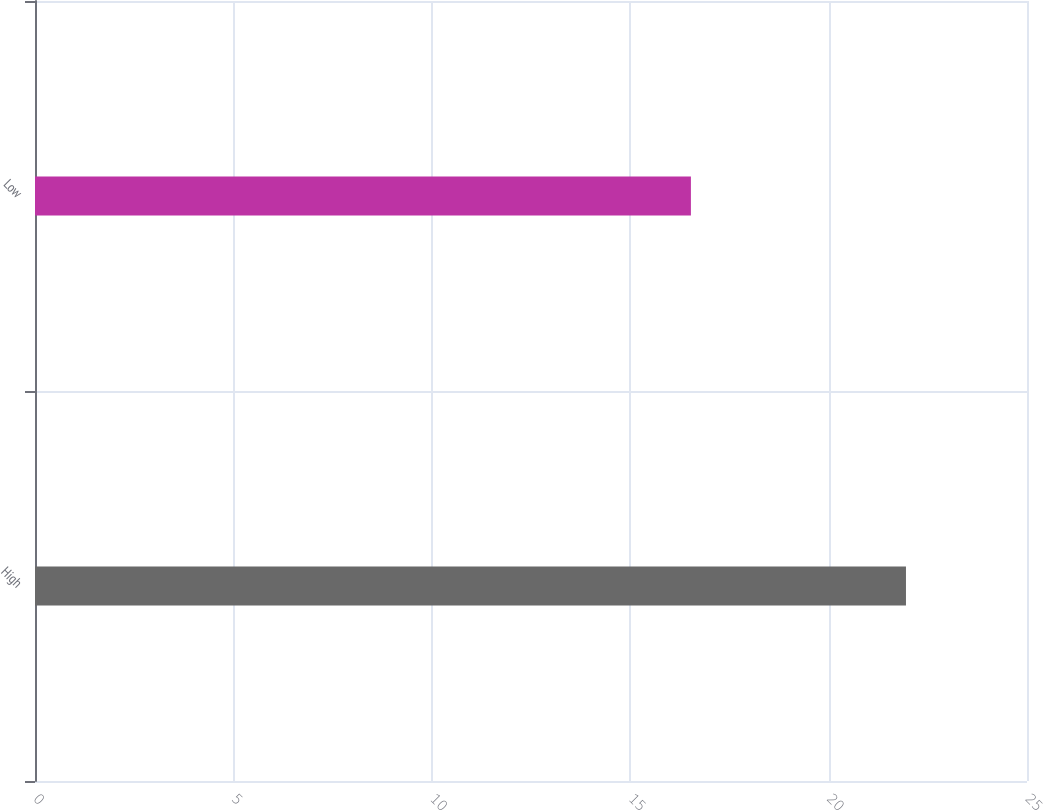<chart> <loc_0><loc_0><loc_500><loc_500><bar_chart><fcel>High<fcel>Low<nl><fcel>21.95<fcel>16.53<nl></chart> 